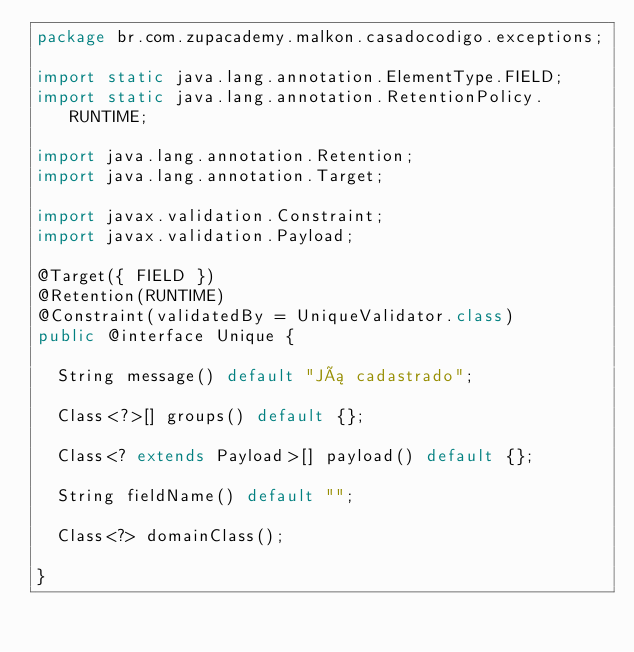<code> <loc_0><loc_0><loc_500><loc_500><_Java_>package br.com.zupacademy.malkon.casadocodigo.exceptions;

import static java.lang.annotation.ElementType.FIELD;
import static java.lang.annotation.RetentionPolicy.RUNTIME;

import java.lang.annotation.Retention;
import java.lang.annotation.Target;

import javax.validation.Constraint;
import javax.validation.Payload;

@Target({ FIELD })
@Retention(RUNTIME)
@Constraint(validatedBy = UniqueValidator.class)
public @interface Unique {

	String message() default "Já cadastrado";

	Class<?>[] groups() default {};

	Class<? extends Payload>[] payload() default {};

	String fieldName() default "";

	Class<?> domainClass();

}
</code> 